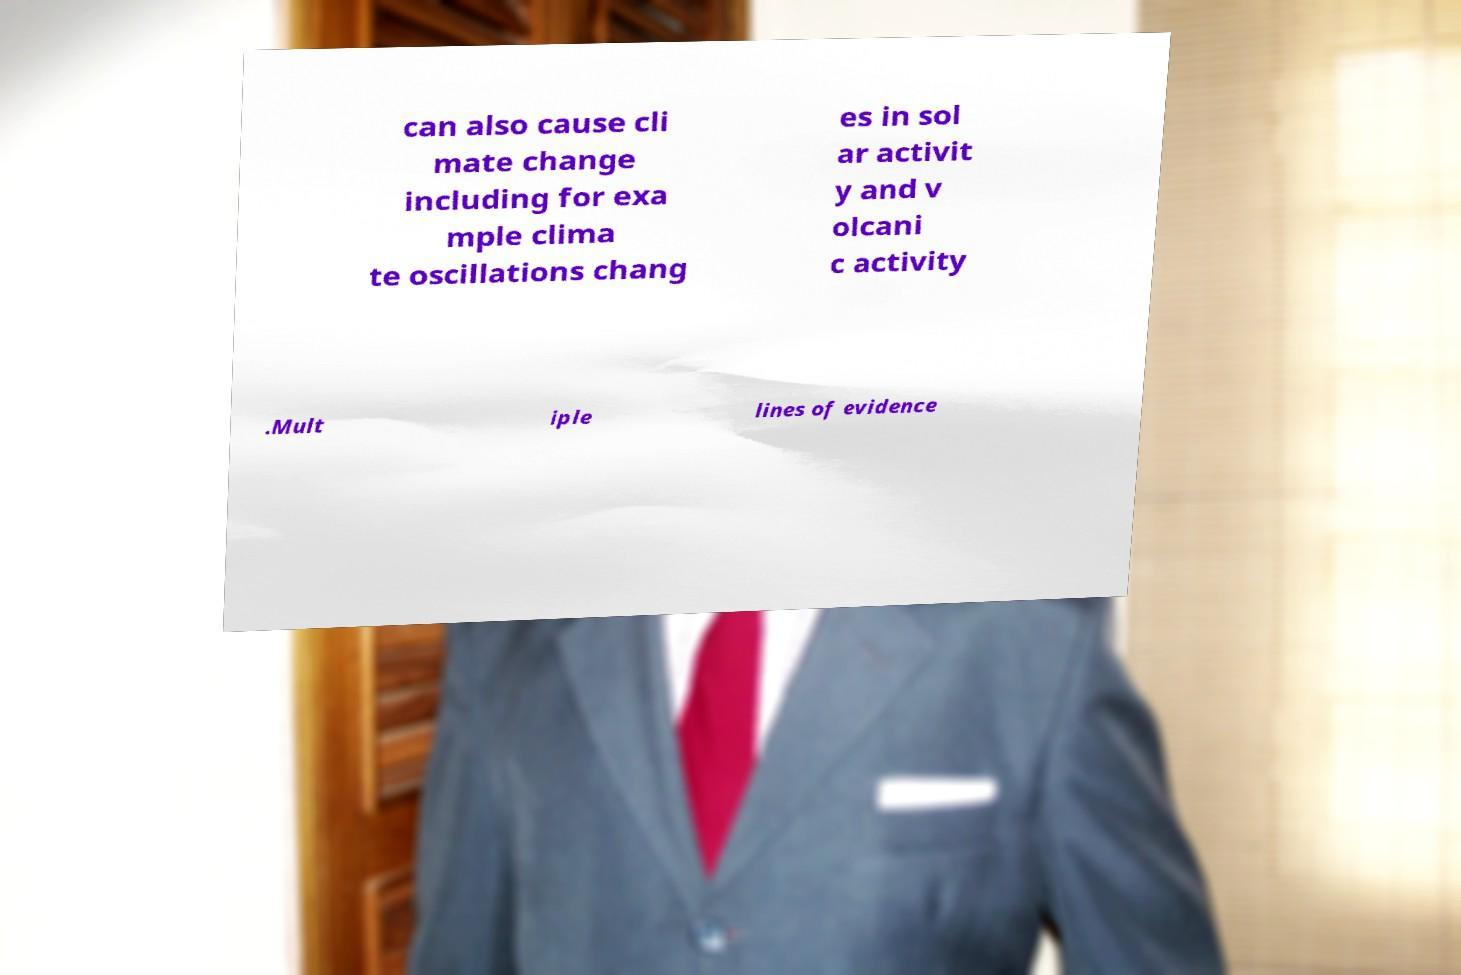Can you accurately transcribe the text from the provided image for me? can also cause cli mate change including for exa mple clima te oscillations chang es in sol ar activit y and v olcani c activity .Mult iple lines of evidence 